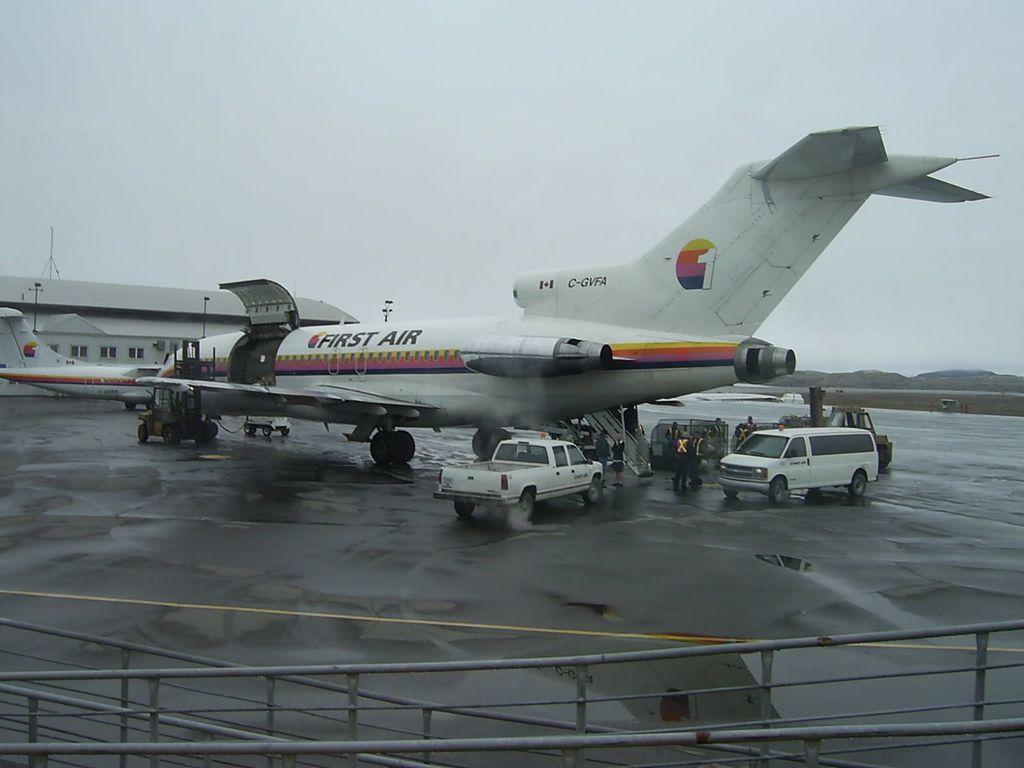Please provide a concise description of this image. This is an aeroplane in white color, there are two vehicles on the road at the top it's a cloudy sky. 